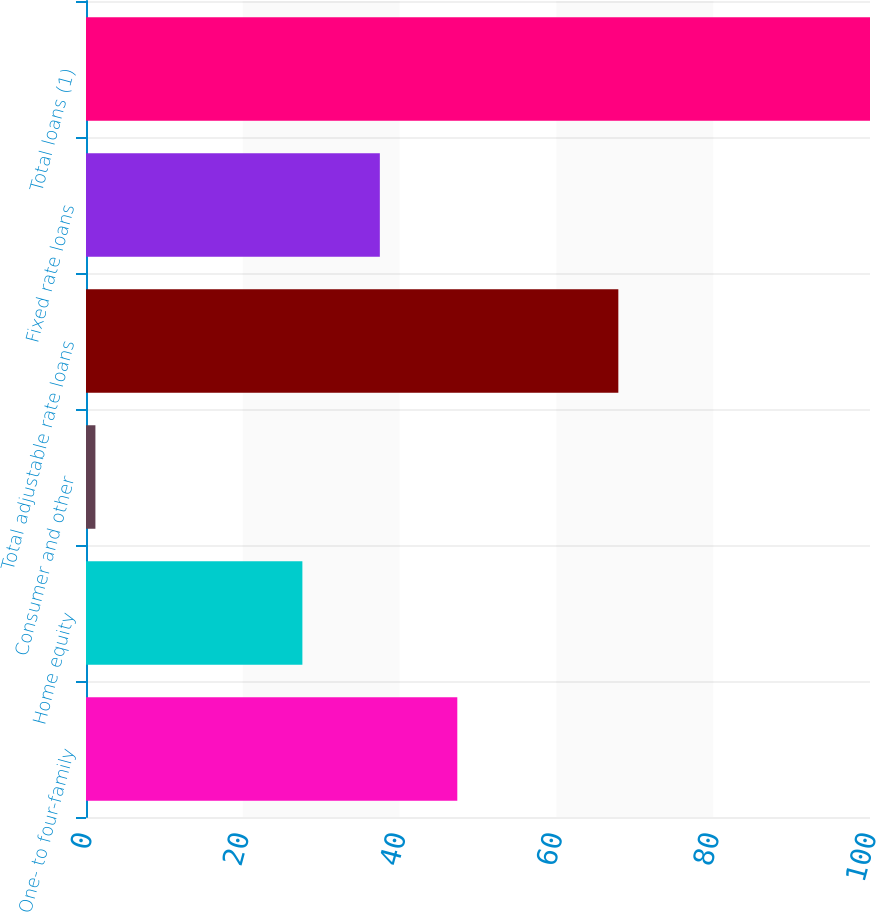<chart> <loc_0><loc_0><loc_500><loc_500><bar_chart><fcel>One- to four-family<fcel>Home equity<fcel>Consumer and other<fcel>Total adjustable rate loans<fcel>Fixed rate loans<fcel>Total loans (1)<nl><fcel>47.36<fcel>27.6<fcel>1.2<fcel>67.9<fcel>37.48<fcel>100<nl></chart> 